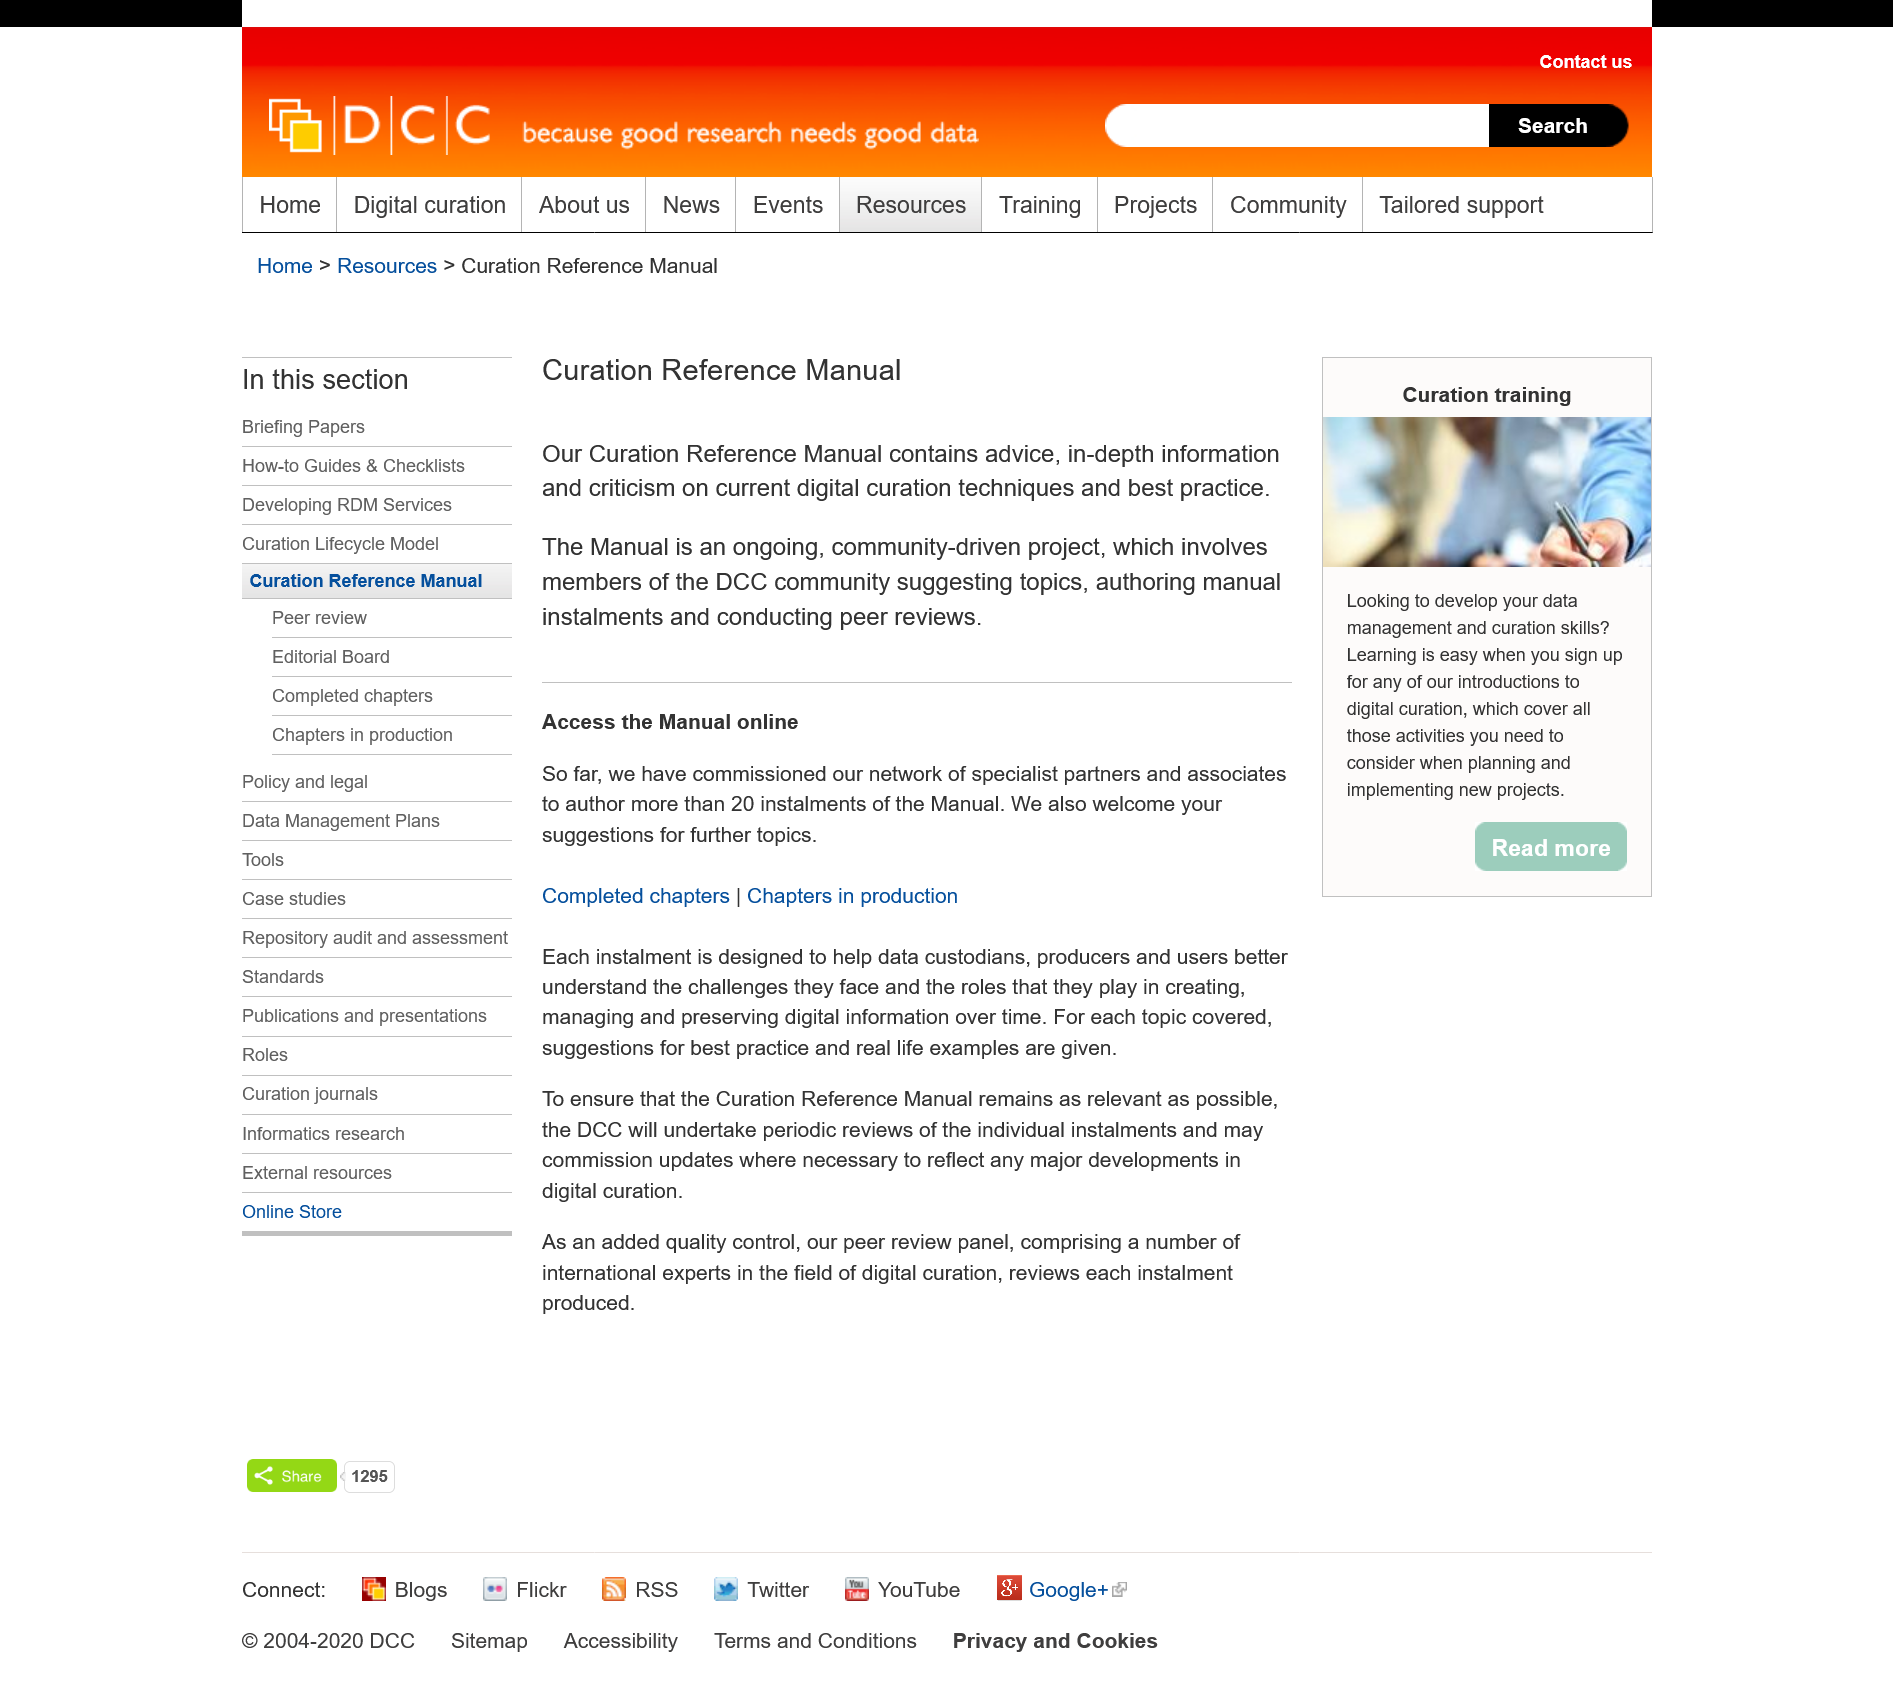Outline some significant characteristics in this image. The Curation Reference Manual is written by members of the DCC community. Peer reviews are conducted in the manual. The Curation Reference Manual contains criticism on current digital curation techniques. 